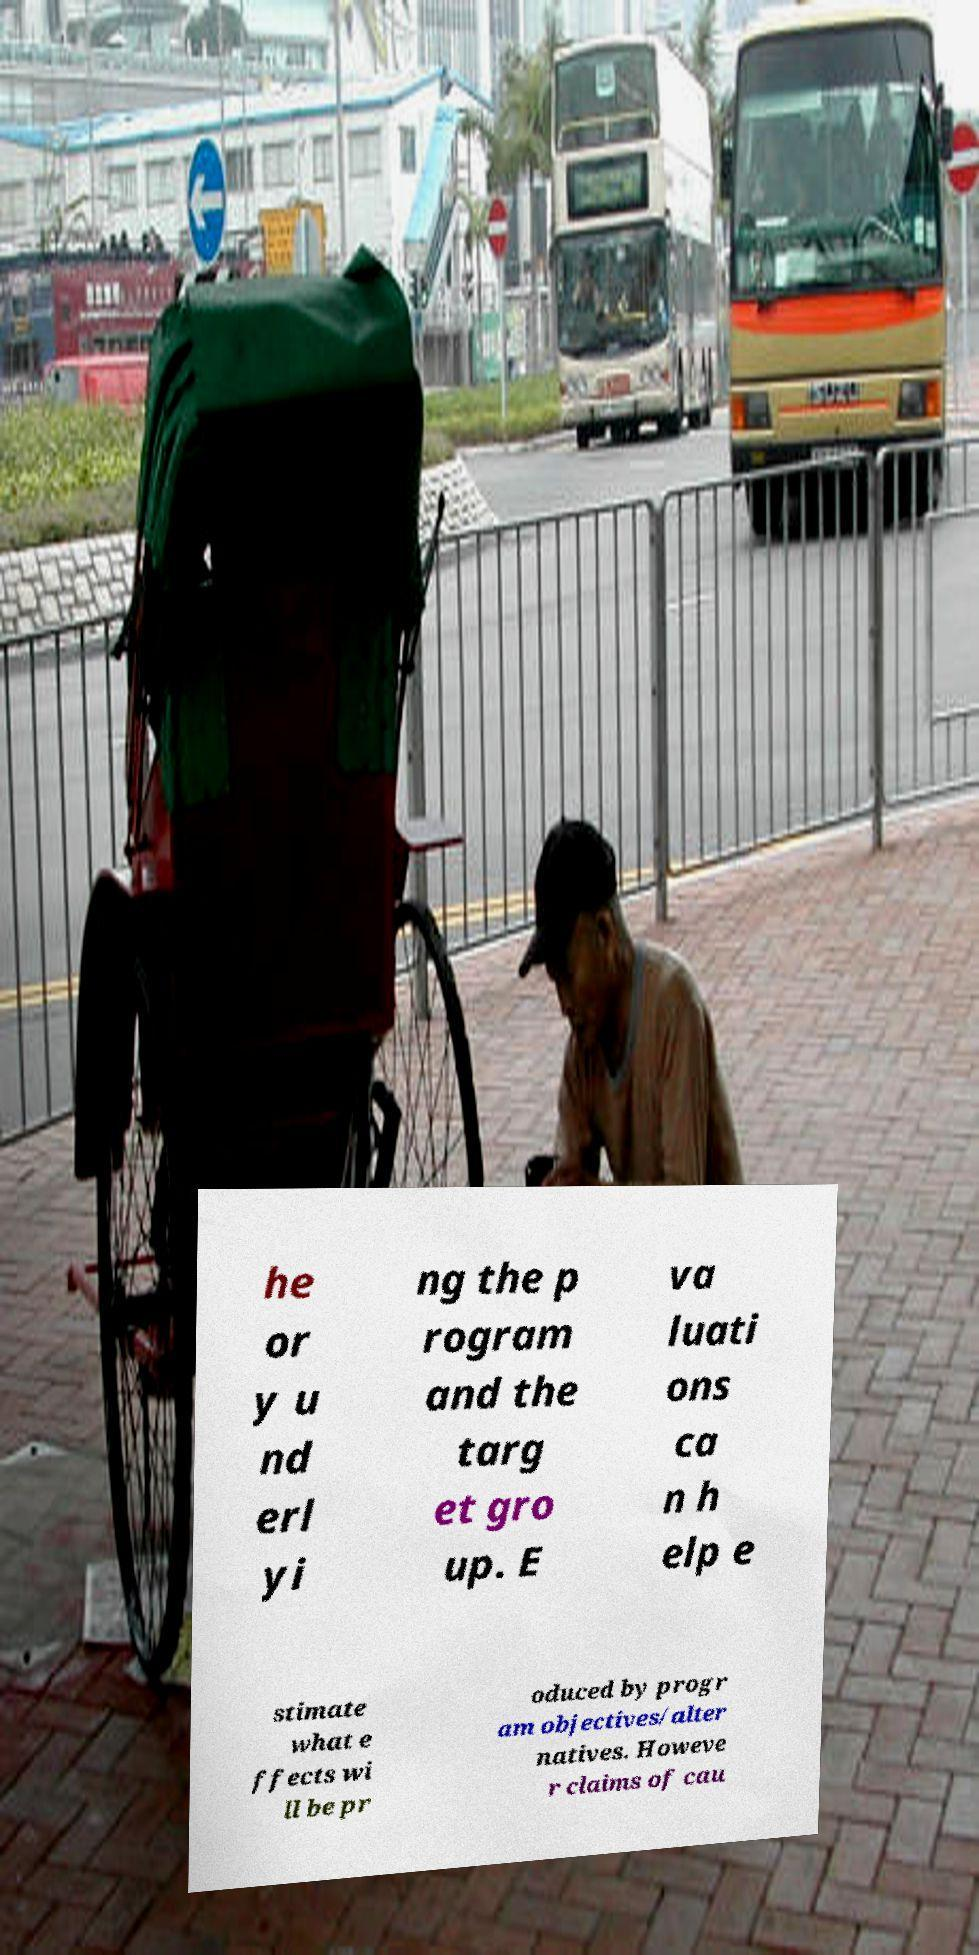Could you assist in decoding the text presented in this image and type it out clearly? he or y u nd erl yi ng the p rogram and the targ et gro up. E va luati ons ca n h elp e stimate what e ffects wi ll be pr oduced by progr am objectives/alter natives. Howeve r claims of cau 